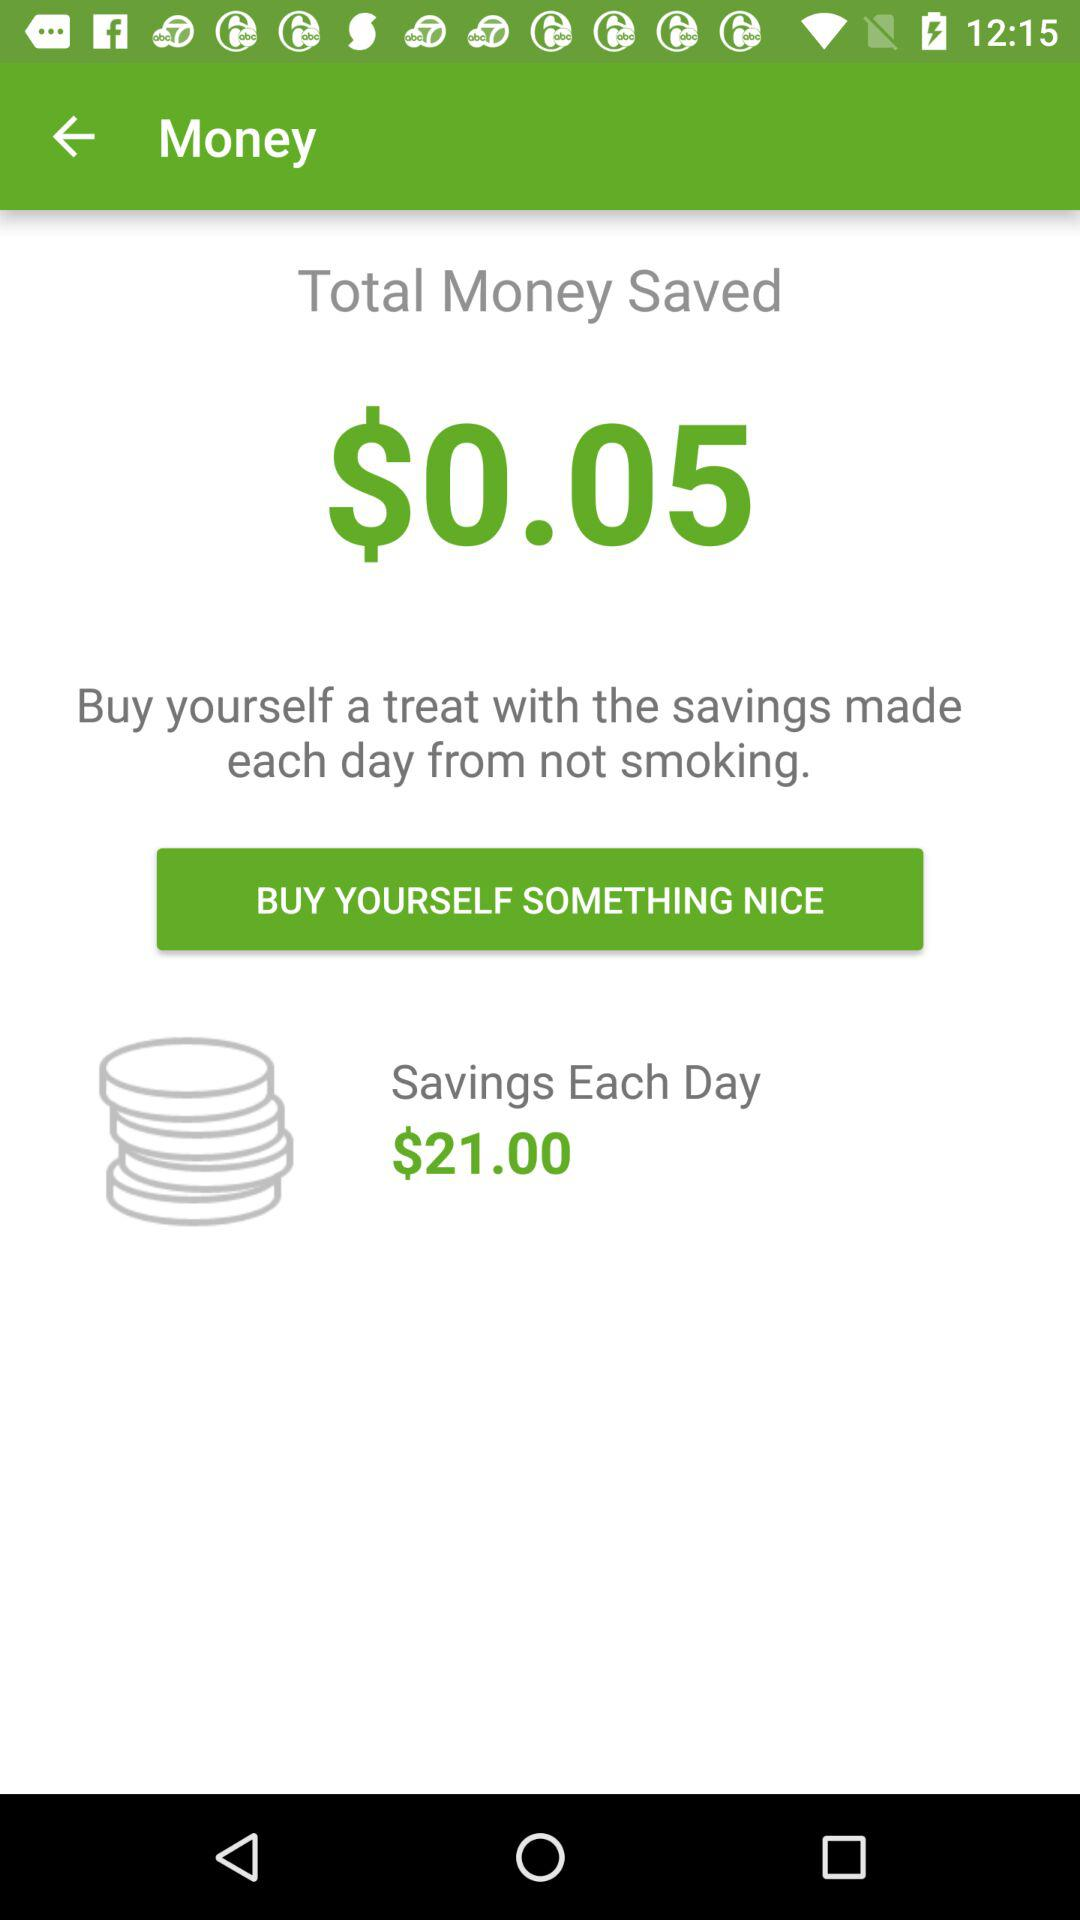How much money have I saved by not smoking today?
Answer the question using a single word or phrase. $0.05 